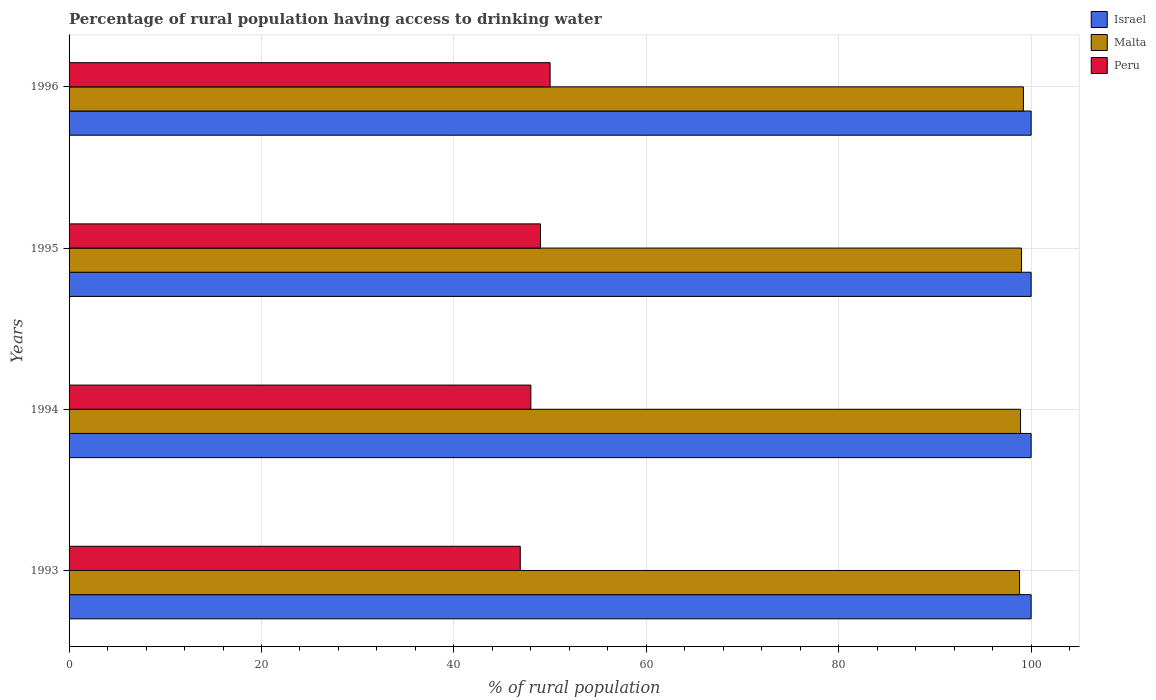How many different coloured bars are there?
Ensure brevity in your answer.  3. How many groups of bars are there?
Provide a short and direct response. 4. Are the number of bars on each tick of the Y-axis equal?
Keep it short and to the point. Yes. How many bars are there on the 4th tick from the top?
Make the answer very short. 3. What is the label of the 4th group of bars from the top?
Provide a succinct answer. 1993. What is the percentage of rural population having access to drinking water in Peru in 1993?
Make the answer very short. 46.9. Across all years, what is the maximum percentage of rural population having access to drinking water in Peru?
Offer a terse response. 50. Across all years, what is the minimum percentage of rural population having access to drinking water in Israel?
Provide a succinct answer. 100. What is the total percentage of rural population having access to drinking water in Malta in the graph?
Provide a short and direct response. 395.9. What is the difference between the percentage of rural population having access to drinking water in Israel in 1993 and that in 1994?
Make the answer very short. 0. What is the difference between the percentage of rural population having access to drinking water in Malta in 1994 and the percentage of rural population having access to drinking water in Israel in 1996?
Give a very brief answer. -1.1. What is the average percentage of rural population having access to drinking water in Malta per year?
Provide a short and direct response. 98.97. In the year 1993, what is the difference between the percentage of rural population having access to drinking water in Malta and percentage of rural population having access to drinking water in Israel?
Keep it short and to the point. -1.2. What is the ratio of the percentage of rural population having access to drinking water in Malta in 1995 to that in 1996?
Ensure brevity in your answer.  1. Is the percentage of rural population having access to drinking water in Israel in 1993 less than that in 1996?
Your answer should be very brief. No. What is the difference between the highest and the second highest percentage of rural population having access to drinking water in Israel?
Provide a short and direct response. 0. What is the difference between the highest and the lowest percentage of rural population having access to drinking water in Peru?
Keep it short and to the point. 3.1. In how many years, is the percentage of rural population having access to drinking water in Israel greater than the average percentage of rural population having access to drinking water in Israel taken over all years?
Keep it short and to the point. 0. What does the 1st bar from the top in 1995 represents?
Your response must be concise. Peru. What does the 3rd bar from the bottom in 1993 represents?
Your answer should be compact. Peru. Is it the case that in every year, the sum of the percentage of rural population having access to drinking water in Malta and percentage of rural population having access to drinking water in Israel is greater than the percentage of rural population having access to drinking water in Peru?
Your answer should be very brief. Yes. How many bars are there?
Make the answer very short. 12. Are the values on the major ticks of X-axis written in scientific E-notation?
Give a very brief answer. No. Does the graph contain grids?
Your answer should be very brief. Yes. Where does the legend appear in the graph?
Provide a succinct answer. Top right. How are the legend labels stacked?
Your answer should be very brief. Vertical. What is the title of the graph?
Your answer should be compact. Percentage of rural population having access to drinking water. What is the label or title of the X-axis?
Your response must be concise. % of rural population. What is the label or title of the Y-axis?
Offer a very short reply. Years. What is the % of rural population in Malta in 1993?
Give a very brief answer. 98.8. What is the % of rural population in Peru in 1993?
Keep it short and to the point. 46.9. What is the % of rural population in Israel in 1994?
Offer a terse response. 100. What is the % of rural population in Malta in 1994?
Ensure brevity in your answer.  98.9. What is the % of rural population of Israel in 1995?
Your response must be concise. 100. What is the % of rural population of Malta in 1995?
Ensure brevity in your answer.  99. What is the % of rural population of Malta in 1996?
Provide a short and direct response. 99.2. What is the % of rural population of Peru in 1996?
Provide a succinct answer. 50. Across all years, what is the maximum % of rural population in Israel?
Give a very brief answer. 100. Across all years, what is the maximum % of rural population in Malta?
Provide a succinct answer. 99.2. Across all years, what is the maximum % of rural population in Peru?
Ensure brevity in your answer.  50. Across all years, what is the minimum % of rural population in Malta?
Your answer should be compact. 98.8. Across all years, what is the minimum % of rural population of Peru?
Make the answer very short. 46.9. What is the total % of rural population of Malta in the graph?
Keep it short and to the point. 395.9. What is the total % of rural population of Peru in the graph?
Give a very brief answer. 193.9. What is the difference between the % of rural population of Peru in 1993 and that in 1994?
Provide a short and direct response. -1.1. What is the difference between the % of rural population in Malta in 1993 and that in 1995?
Keep it short and to the point. -0.2. What is the difference between the % of rural population of Israel in 1993 and that in 1996?
Give a very brief answer. 0. What is the difference between the % of rural population of Malta in 1993 and that in 1996?
Offer a terse response. -0.4. What is the difference between the % of rural population of Israel in 1994 and that in 1995?
Give a very brief answer. 0. What is the difference between the % of rural population in Malta in 1994 and that in 1995?
Offer a terse response. -0.1. What is the difference between the % of rural population in Israel in 1994 and that in 1996?
Ensure brevity in your answer.  0. What is the difference between the % of rural population in Israel in 1995 and that in 1996?
Give a very brief answer. 0. What is the difference between the % of rural population of Israel in 1993 and the % of rural population of Malta in 1994?
Your answer should be compact. 1.1. What is the difference between the % of rural population in Malta in 1993 and the % of rural population in Peru in 1994?
Provide a succinct answer. 50.8. What is the difference between the % of rural population of Israel in 1993 and the % of rural population of Peru in 1995?
Keep it short and to the point. 51. What is the difference between the % of rural population of Malta in 1993 and the % of rural population of Peru in 1995?
Your answer should be very brief. 49.8. What is the difference between the % of rural population of Israel in 1993 and the % of rural population of Malta in 1996?
Make the answer very short. 0.8. What is the difference between the % of rural population of Israel in 1993 and the % of rural population of Peru in 1996?
Make the answer very short. 50. What is the difference between the % of rural population in Malta in 1993 and the % of rural population in Peru in 1996?
Offer a terse response. 48.8. What is the difference between the % of rural population in Israel in 1994 and the % of rural population in Malta in 1995?
Offer a terse response. 1. What is the difference between the % of rural population in Israel in 1994 and the % of rural population in Peru in 1995?
Your answer should be compact. 51. What is the difference between the % of rural population in Malta in 1994 and the % of rural population in Peru in 1995?
Your response must be concise. 49.9. What is the difference between the % of rural population in Israel in 1994 and the % of rural population in Malta in 1996?
Your answer should be very brief. 0.8. What is the difference between the % of rural population in Malta in 1994 and the % of rural population in Peru in 1996?
Offer a very short reply. 48.9. What is the average % of rural population of Malta per year?
Offer a very short reply. 98.97. What is the average % of rural population of Peru per year?
Your answer should be very brief. 48.48. In the year 1993, what is the difference between the % of rural population in Israel and % of rural population in Peru?
Ensure brevity in your answer.  53.1. In the year 1993, what is the difference between the % of rural population of Malta and % of rural population of Peru?
Ensure brevity in your answer.  51.9. In the year 1994, what is the difference between the % of rural population in Israel and % of rural population in Peru?
Make the answer very short. 52. In the year 1994, what is the difference between the % of rural population in Malta and % of rural population in Peru?
Provide a short and direct response. 50.9. In the year 1995, what is the difference between the % of rural population of Malta and % of rural population of Peru?
Your answer should be very brief. 50. In the year 1996, what is the difference between the % of rural population of Israel and % of rural population of Malta?
Your response must be concise. 0.8. In the year 1996, what is the difference between the % of rural population of Malta and % of rural population of Peru?
Ensure brevity in your answer.  49.2. What is the ratio of the % of rural population in Israel in 1993 to that in 1994?
Offer a terse response. 1. What is the ratio of the % of rural population in Malta in 1993 to that in 1994?
Your answer should be compact. 1. What is the ratio of the % of rural population in Peru in 1993 to that in 1994?
Provide a short and direct response. 0.98. What is the ratio of the % of rural population in Israel in 1993 to that in 1995?
Give a very brief answer. 1. What is the ratio of the % of rural population in Peru in 1993 to that in 1995?
Your answer should be compact. 0.96. What is the ratio of the % of rural population of Malta in 1993 to that in 1996?
Provide a short and direct response. 1. What is the ratio of the % of rural population in Peru in 1993 to that in 1996?
Your answer should be very brief. 0.94. What is the ratio of the % of rural population of Peru in 1994 to that in 1995?
Offer a very short reply. 0.98. What is the ratio of the % of rural population in Malta in 1994 to that in 1996?
Provide a short and direct response. 1. What is the ratio of the % of rural population of Malta in 1995 to that in 1996?
Your response must be concise. 1. What is the difference between the highest and the second highest % of rural population of Israel?
Offer a very short reply. 0. What is the difference between the highest and the second highest % of rural population in Malta?
Make the answer very short. 0.2. What is the difference between the highest and the second highest % of rural population of Peru?
Offer a terse response. 1. What is the difference between the highest and the lowest % of rural population of Israel?
Ensure brevity in your answer.  0. What is the difference between the highest and the lowest % of rural population in Peru?
Your answer should be compact. 3.1. 